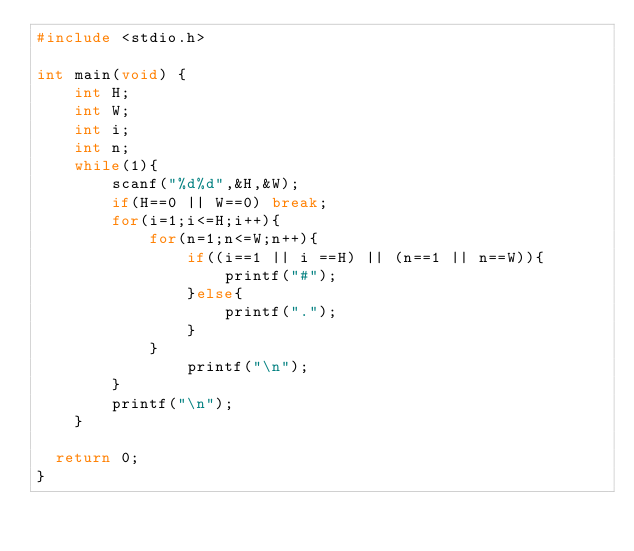<code> <loc_0><loc_0><loc_500><loc_500><_C_>#include <stdio.h>

int main(void) {
    int H;
    int W;
    int i;
    int n;
    while(1){
        scanf("%d%d",&H,&W);
        if(H==0 || W==0) break;
        for(i=1;i<=H;i++){
            for(n=1;n<=W;n++){
                if((i==1 || i ==H) || (n==1 || n==W)){
                    printf("#");
                }else{
                    printf(".");
                }
            }
                printf("\n");
        }
        printf("\n");
    }
   
	return 0;
}


</code> 